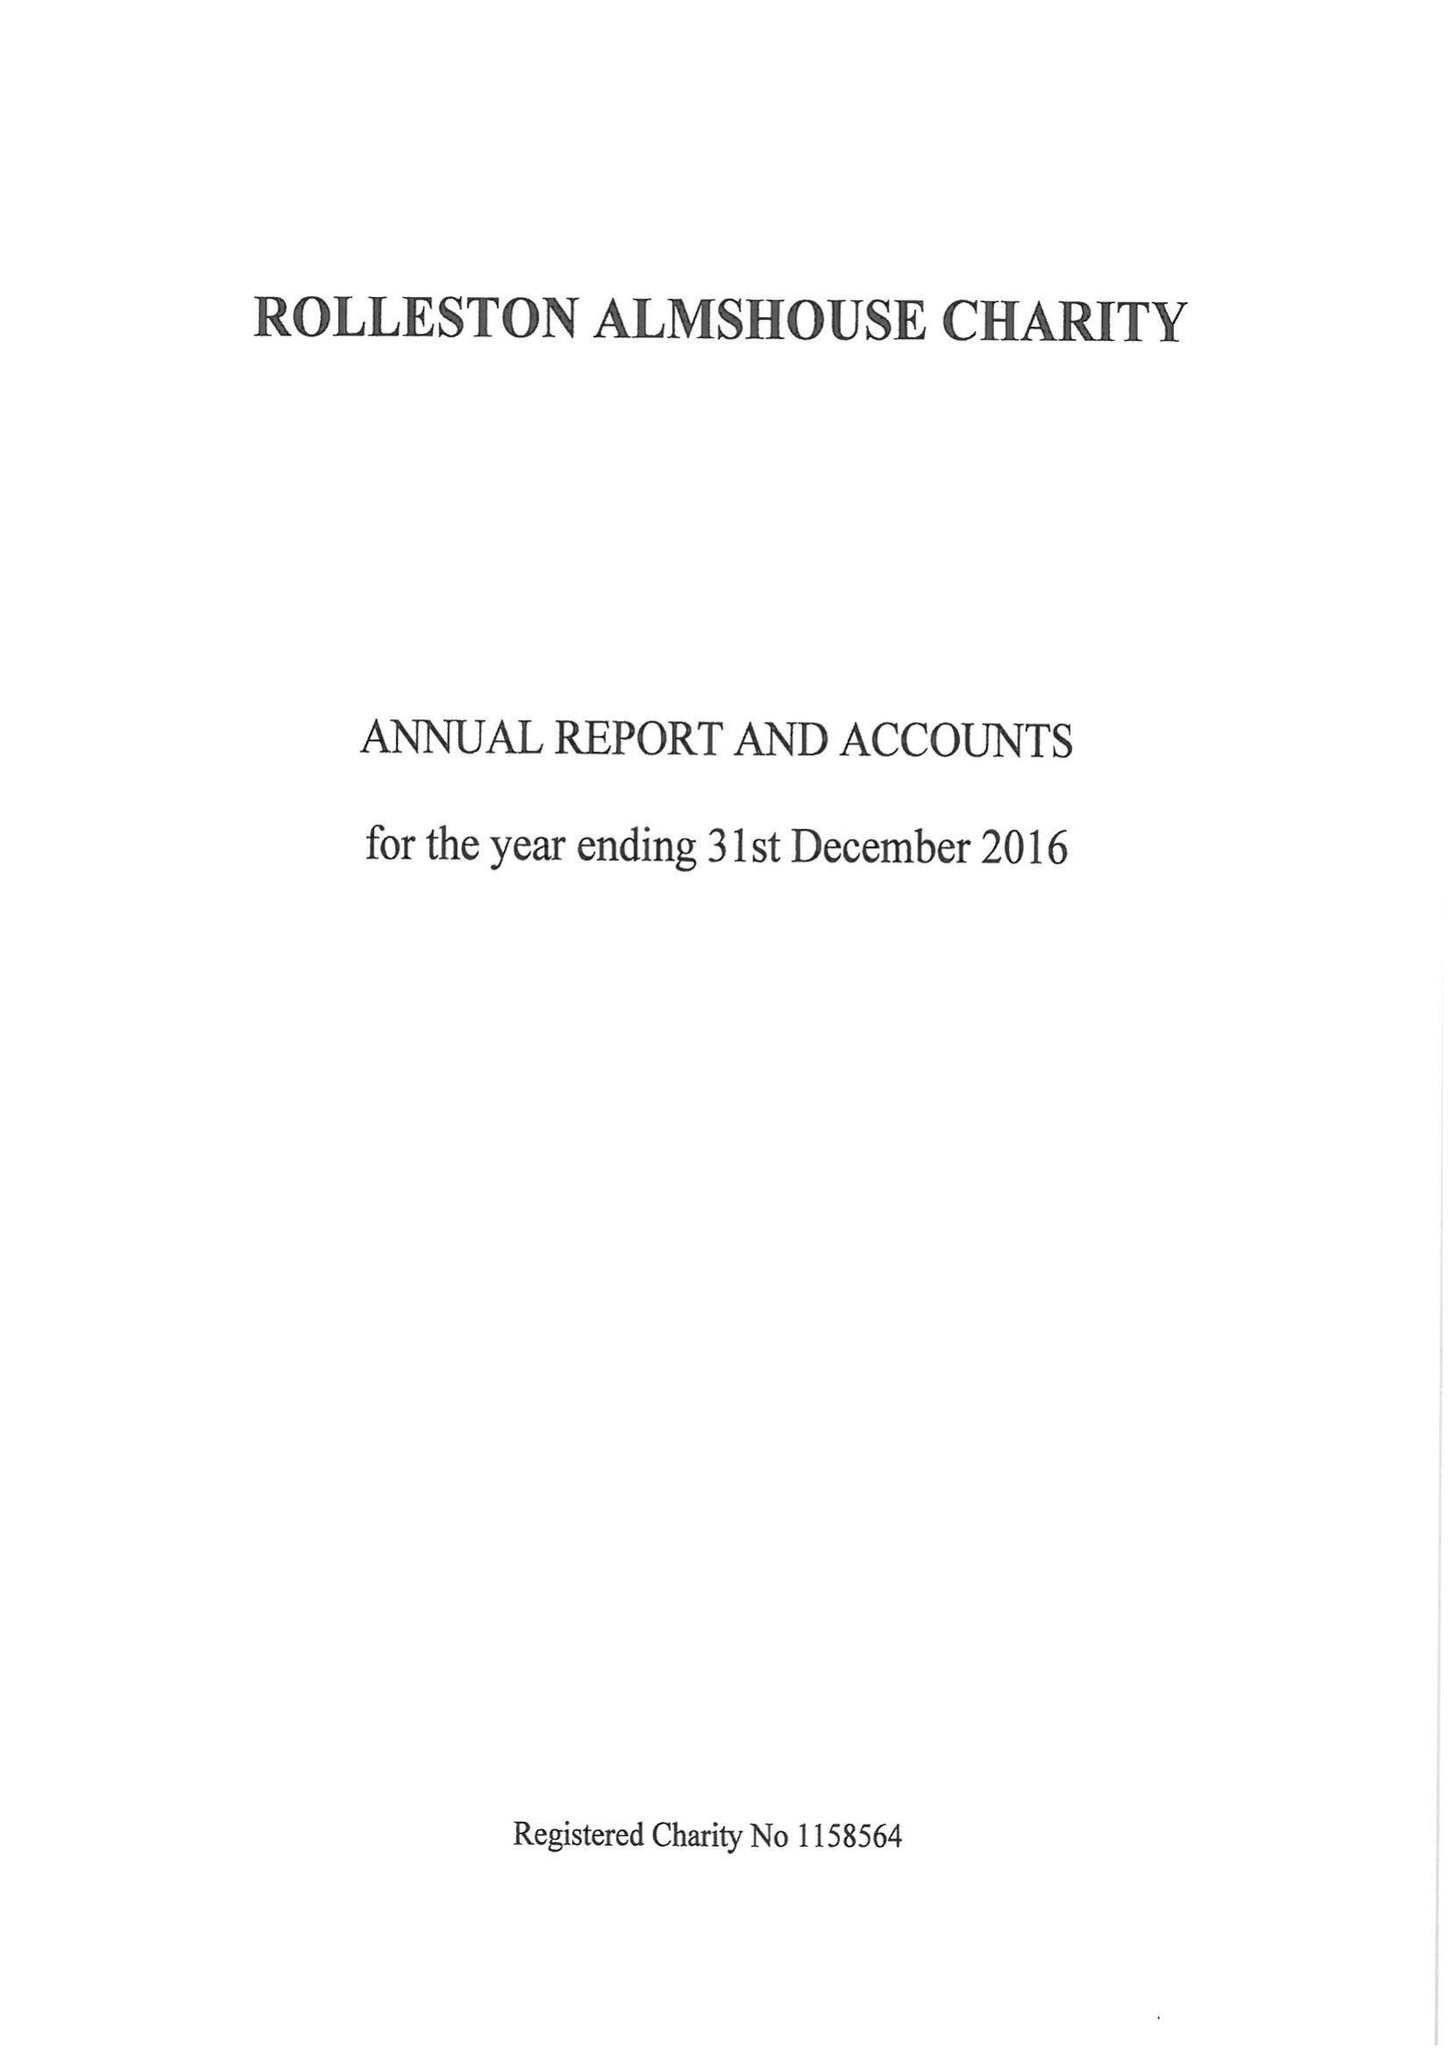What is the value for the address__post_town?
Answer the question using a single word or phrase. BURTON-ON-TRENT 